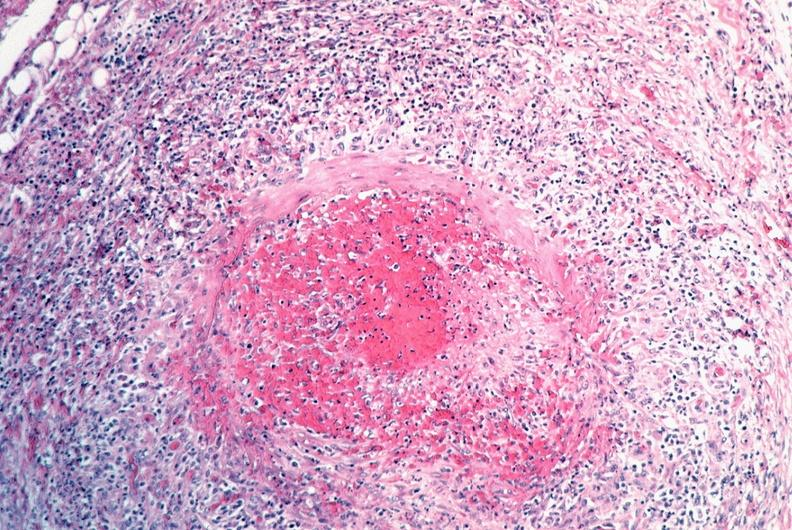what is present?
Answer the question using a single word or phrase. Cardiovascular 